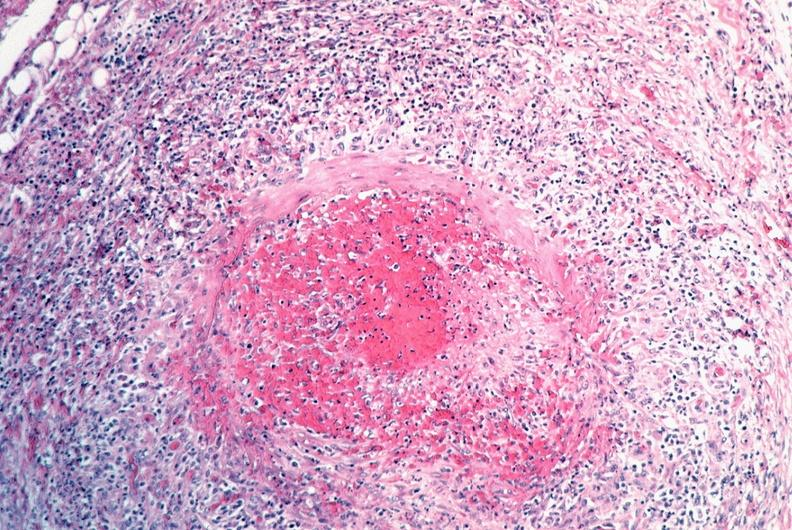what is present?
Answer the question using a single word or phrase. Cardiovascular 